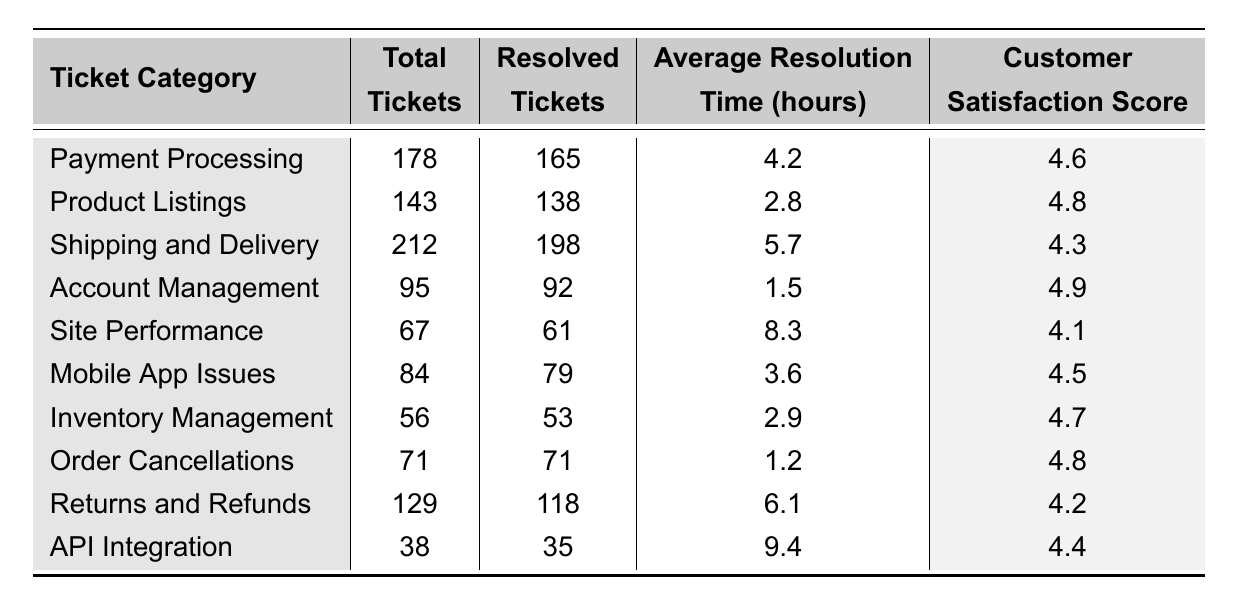What is the total number of tickets in the "Shipping and Delivery" category? The table shows that there are 212 total tickets under the "Shipping and Delivery" category.
Answer: 212 How many tickets were resolved in the "Payment Processing" category? The table indicates that 165 tickets were resolved in the "Payment Processing" category.
Answer: 165 What is the average resolution time for "Site Performance" tickets? According to the table, the average resolution time for "Site Performance" tickets is 8.3 hours.
Answer: 8.3 Which ticket category has the highest customer satisfaction score? The highest customer satisfaction score is 4.9, found in the "Account Management" category.
Answer: Account Management How many more total tickets were submitted in "Shipping and Delivery" compared to "API Integration"? "Shipping and Delivery" has 212 total tickets, and "API Integration" has 38 tickets. The difference is 212 - 38 = 174.
Answer: 174 What is the total number of resolved tickets across all categories? By summing all resolved tickets (165 + 138 + 198 + 92 + 61 + 79 + 53 + 71 + 118 + 35), we get a total of 1,010 resolved tickets.
Answer: 1010 Which category has the least total tickets? "API Integration" has the least total tickets at 38.
Answer: API Integration Is the average resolution time for "Returns and Refunds" less than for "Mobile App Issues"? The average resolution time for "Returns and Refunds" is 6.1 hours, and for "Mobile App Issues," it is 3.6 hours. Thus, the statement is false.
Answer: No What is the difference in customer satisfaction score between "Order Cancellations" and "Shipping and Delivery"? The score for "Order Cancellations" is 4.8, and for "Shipping and Delivery," it is 4.3. The difference is 4.8 - 4.3 = 0.5.
Answer: 0.5 What is the average customer satisfaction score across all categories? The average customer satisfaction score can be calculated by adding all scores (4.6 + 4.8 + 4.3 + 4.9 + 4.1 + 4.5 + 4.7 + 4.8 + 4.2 + 4.4) and dividing by 10, which results in 4.49.
Answer: 4.49 